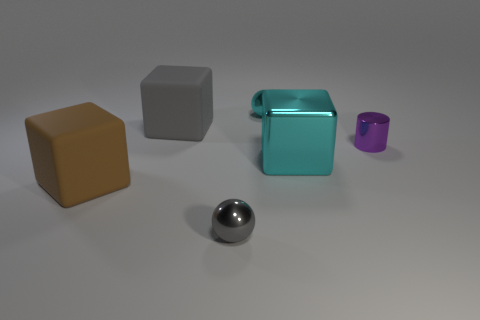Imagine if these objects were part of a puzzle, how could they be used to solve it? If these objects were part of a puzzle, they could be used in different ways based on their shapes, colors, and textures. For example, they could be fit into corresponding silhouettes on a board, or perhaps they must be arranged by texture or color gradient. Additionally, if the puzzle involved physics, the reflective sphere could be part of a light path puzzle where its position reflects light to a specific target. 